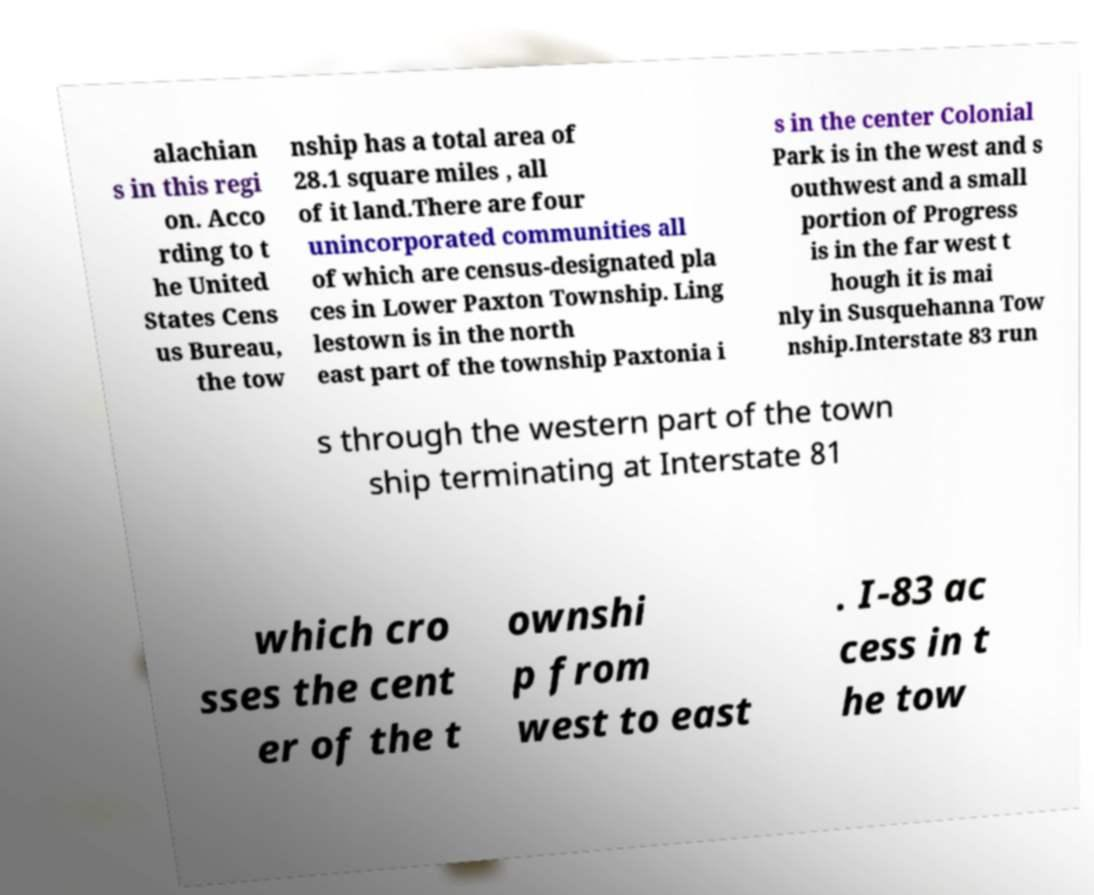Please identify and transcribe the text found in this image. alachian s in this regi on. Acco rding to t he United States Cens us Bureau, the tow nship has a total area of 28.1 square miles , all of it land.There are four unincorporated communities all of which are census-designated pla ces in Lower Paxton Township. Ling lestown is in the north east part of the township Paxtonia i s in the center Colonial Park is in the west and s outhwest and a small portion of Progress is in the far west t hough it is mai nly in Susquehanna Tow nship.Interstate 83 run s through the western part of the town ship terminating at Interstate 81 which cro sses the cent er of the t ownshi p from west to east . I-83 ac cess in t he tow 